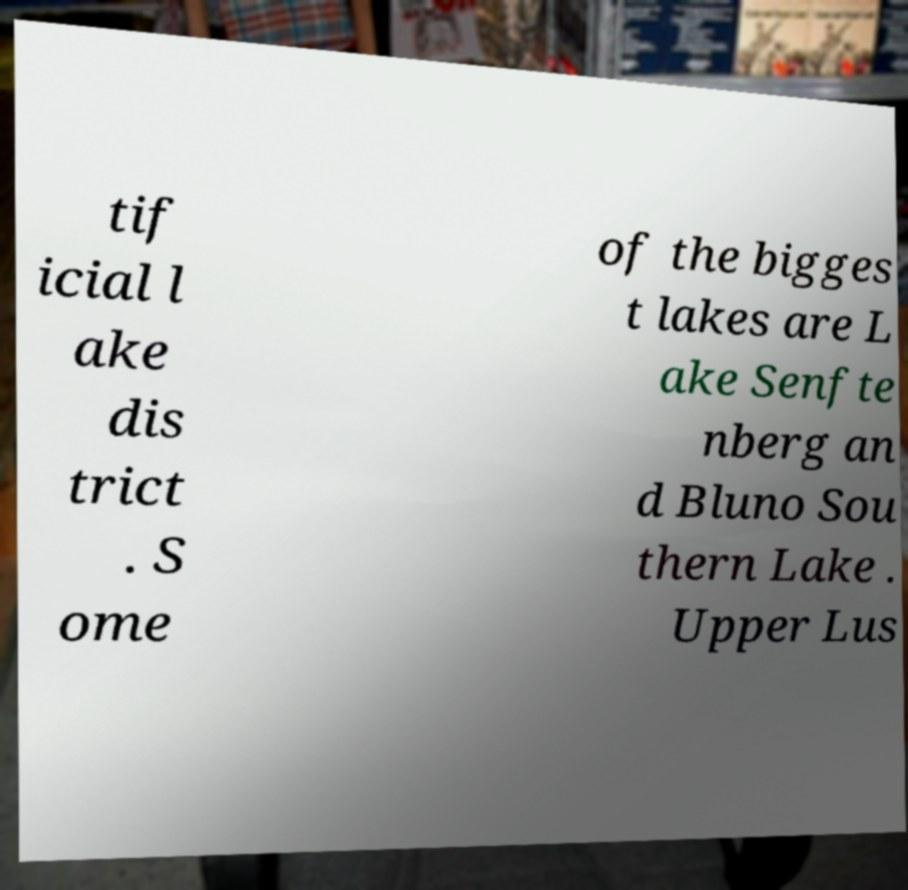For documentation purposes, I need the text within this image transcribed. Could you provide that? tif icial l ake dis trict . S ome of the bigges t lakes are L ake Senfte nberg an d Bluno Sou thern Lake . Upper Lus 